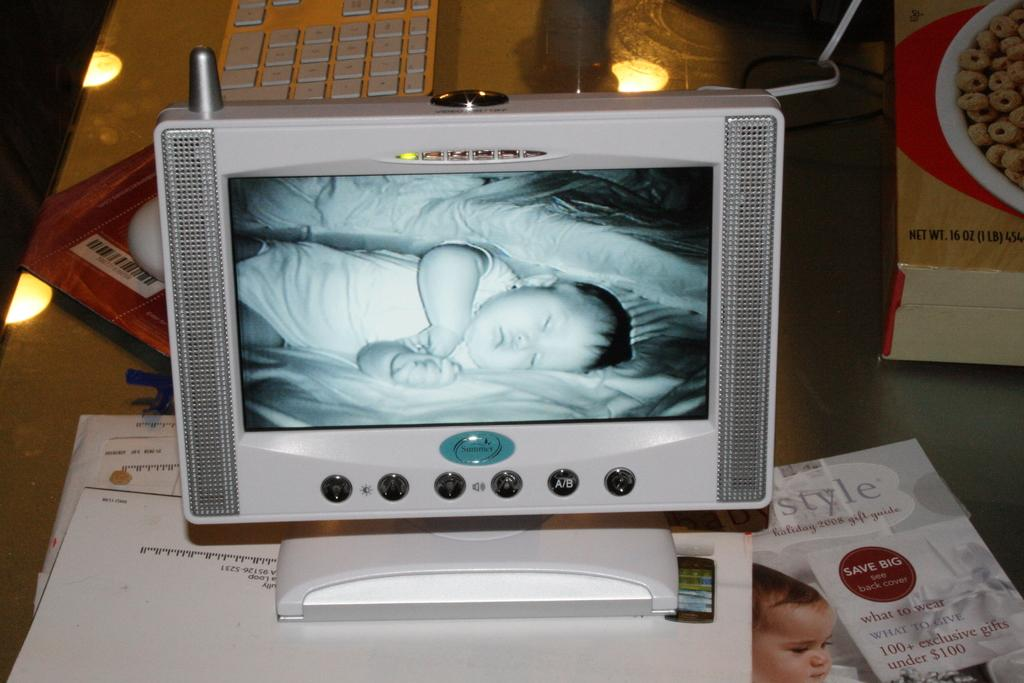<image>
Create a compact narrative representing the image presented. Next to a baby monitor is a gift guide that says save big on the cover. 